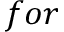Convert formula to latex. <formula><loc_0><loc_0><loc_500><loc_500>f o r</formula> 